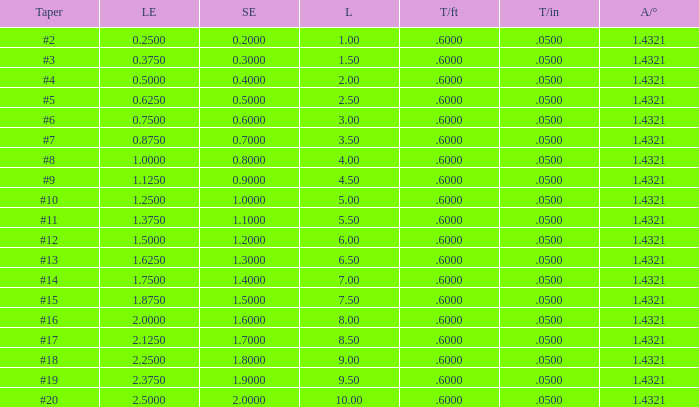In which case does a large end have a taper per foot lower than 0.6000000000000001? 19.0. 